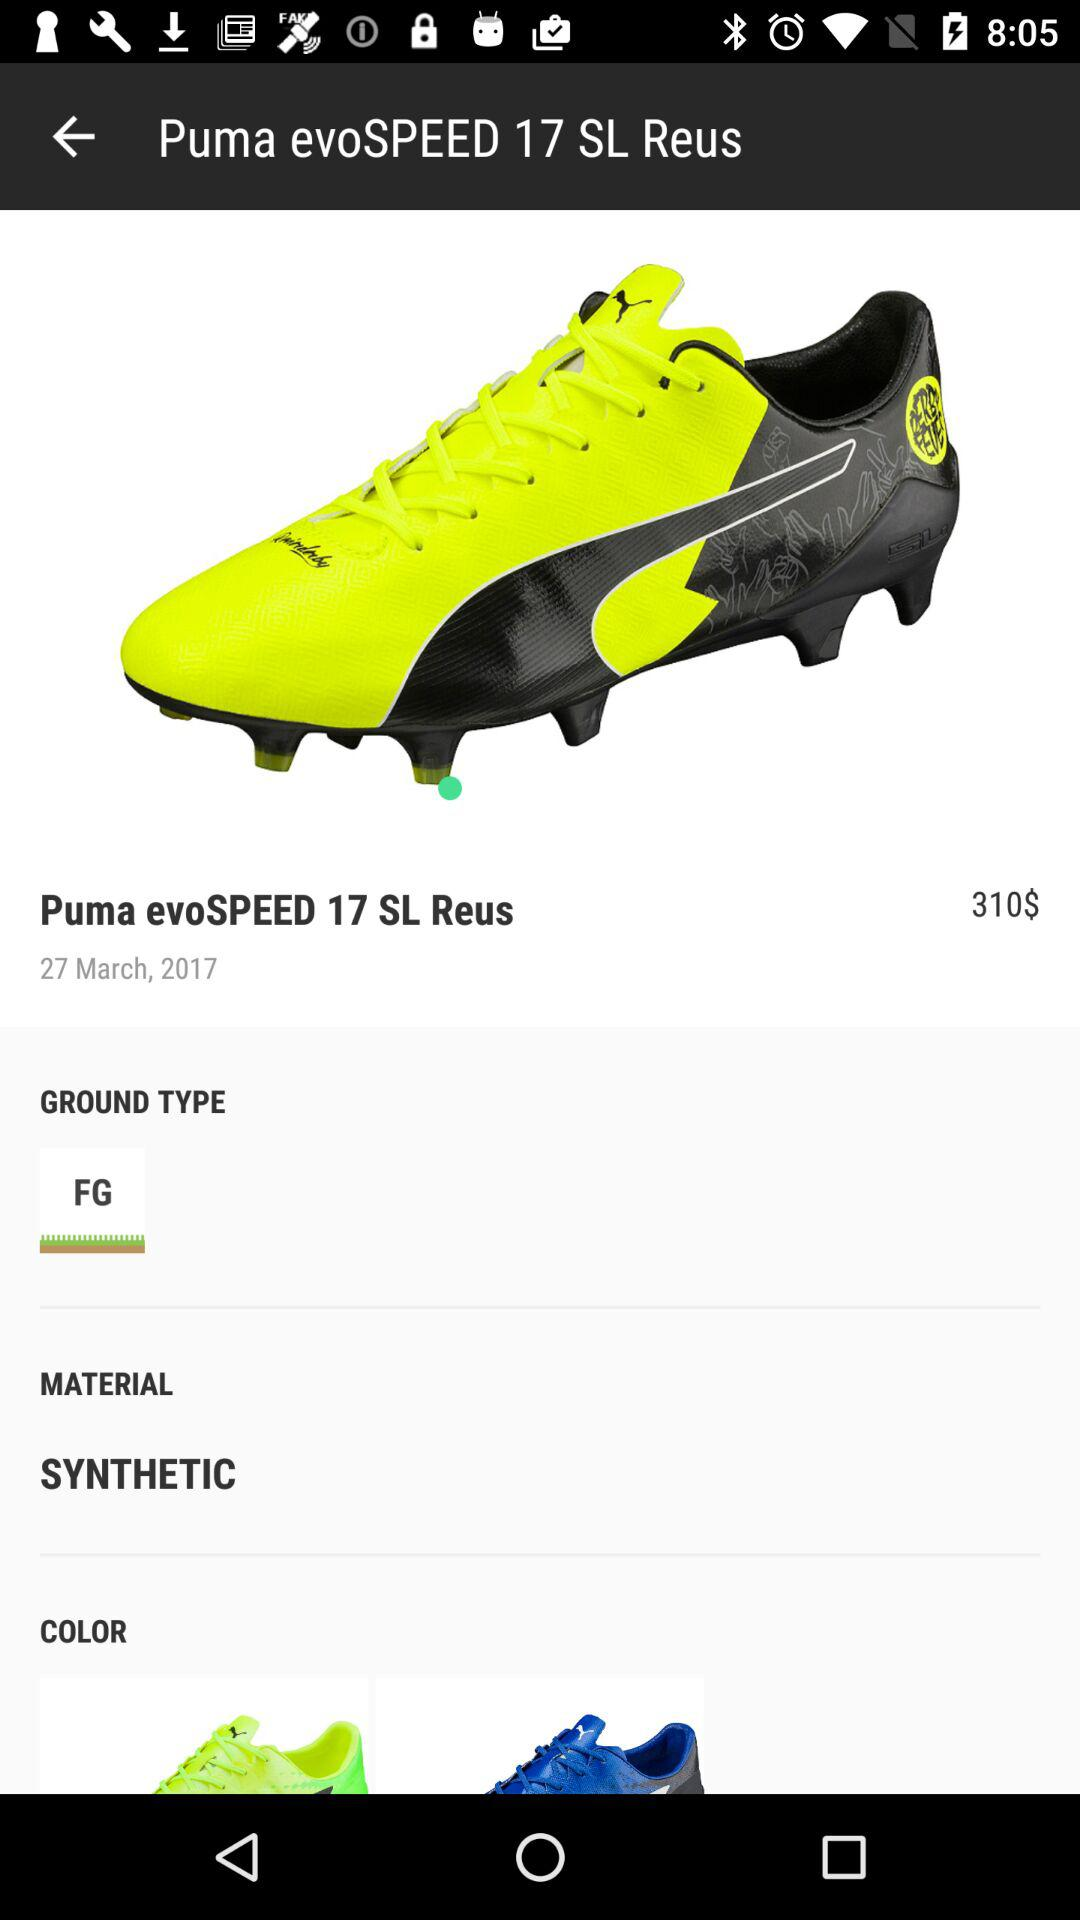What is the date? The date is March 27, 2017. 